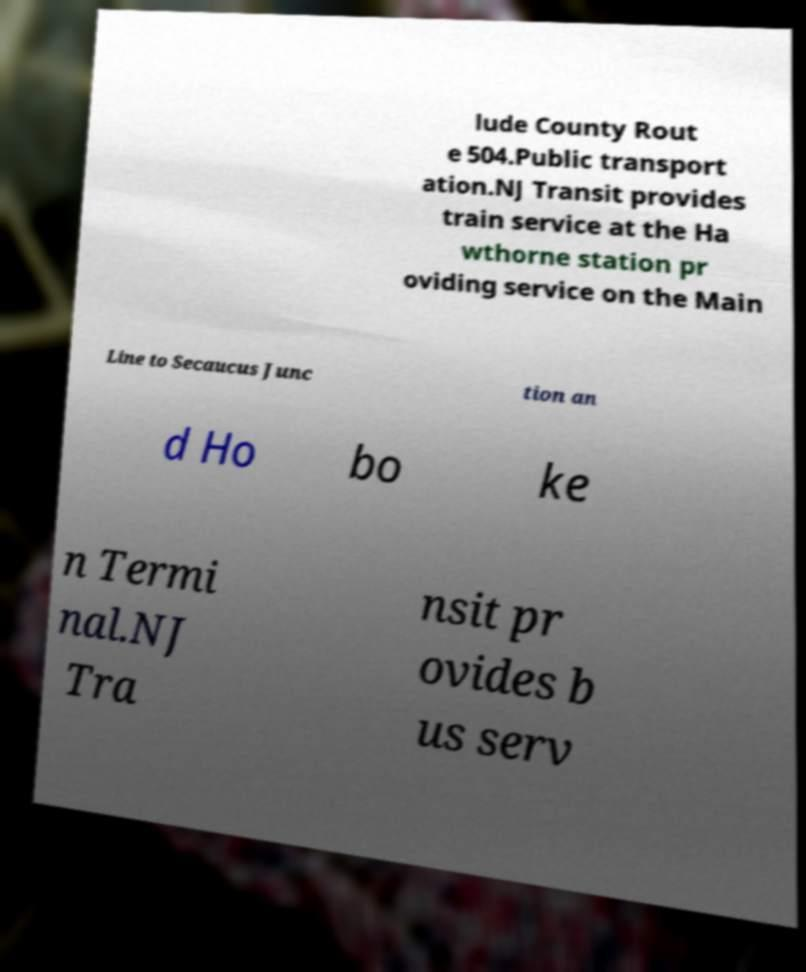Please read and relay the text visible in this image. What does it say? lude County Rout e 504.Public transport ation.NJ Transit provides train service at the Ha wthorne station pr oviding service on the Main Line to Secaucus Junc tion an d Ho bo ke n Termi nal.NJ Tra nsit pr ovides b us serv 